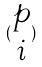Convert formula to latex. <formula><loc_0><loc_0><loc_500><loc_500>( \begin{matrix} p \\ i \end{matrix} )</formula> 